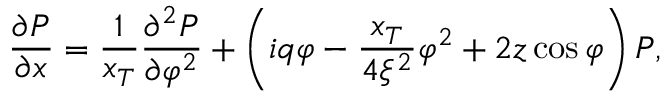Convert formula to latex. <formula><loc_0><loc_0><loc_500><loc_500>\frac { \partial P } { \partial x } = \frac { 1 } { x _ { T } } \frac { \partial ^ { 2 } P } { \partial \varphi ^ { 2 } } + \left ( i q \varphi - \frac { x _ { T } } { 4 \xi ^ { 2 } } \varphi ^ { 2 } + 2 z \cos \varphi \right ) P ,</formula> 